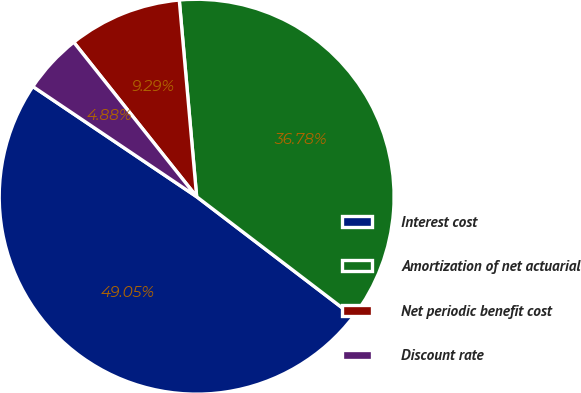Convert chart. <chart><loc_0><loc_0><loc_500><loc_500><pie_chart><fcel>Interest cost<fcel>Amortization of net actuarial<fcel>Net periodic benefit cost<fcel>Discount rate<nl><fcel>49.05%<fcel>36.78%<fcel>9.29%<fcel>4.88%<nl></chart> 